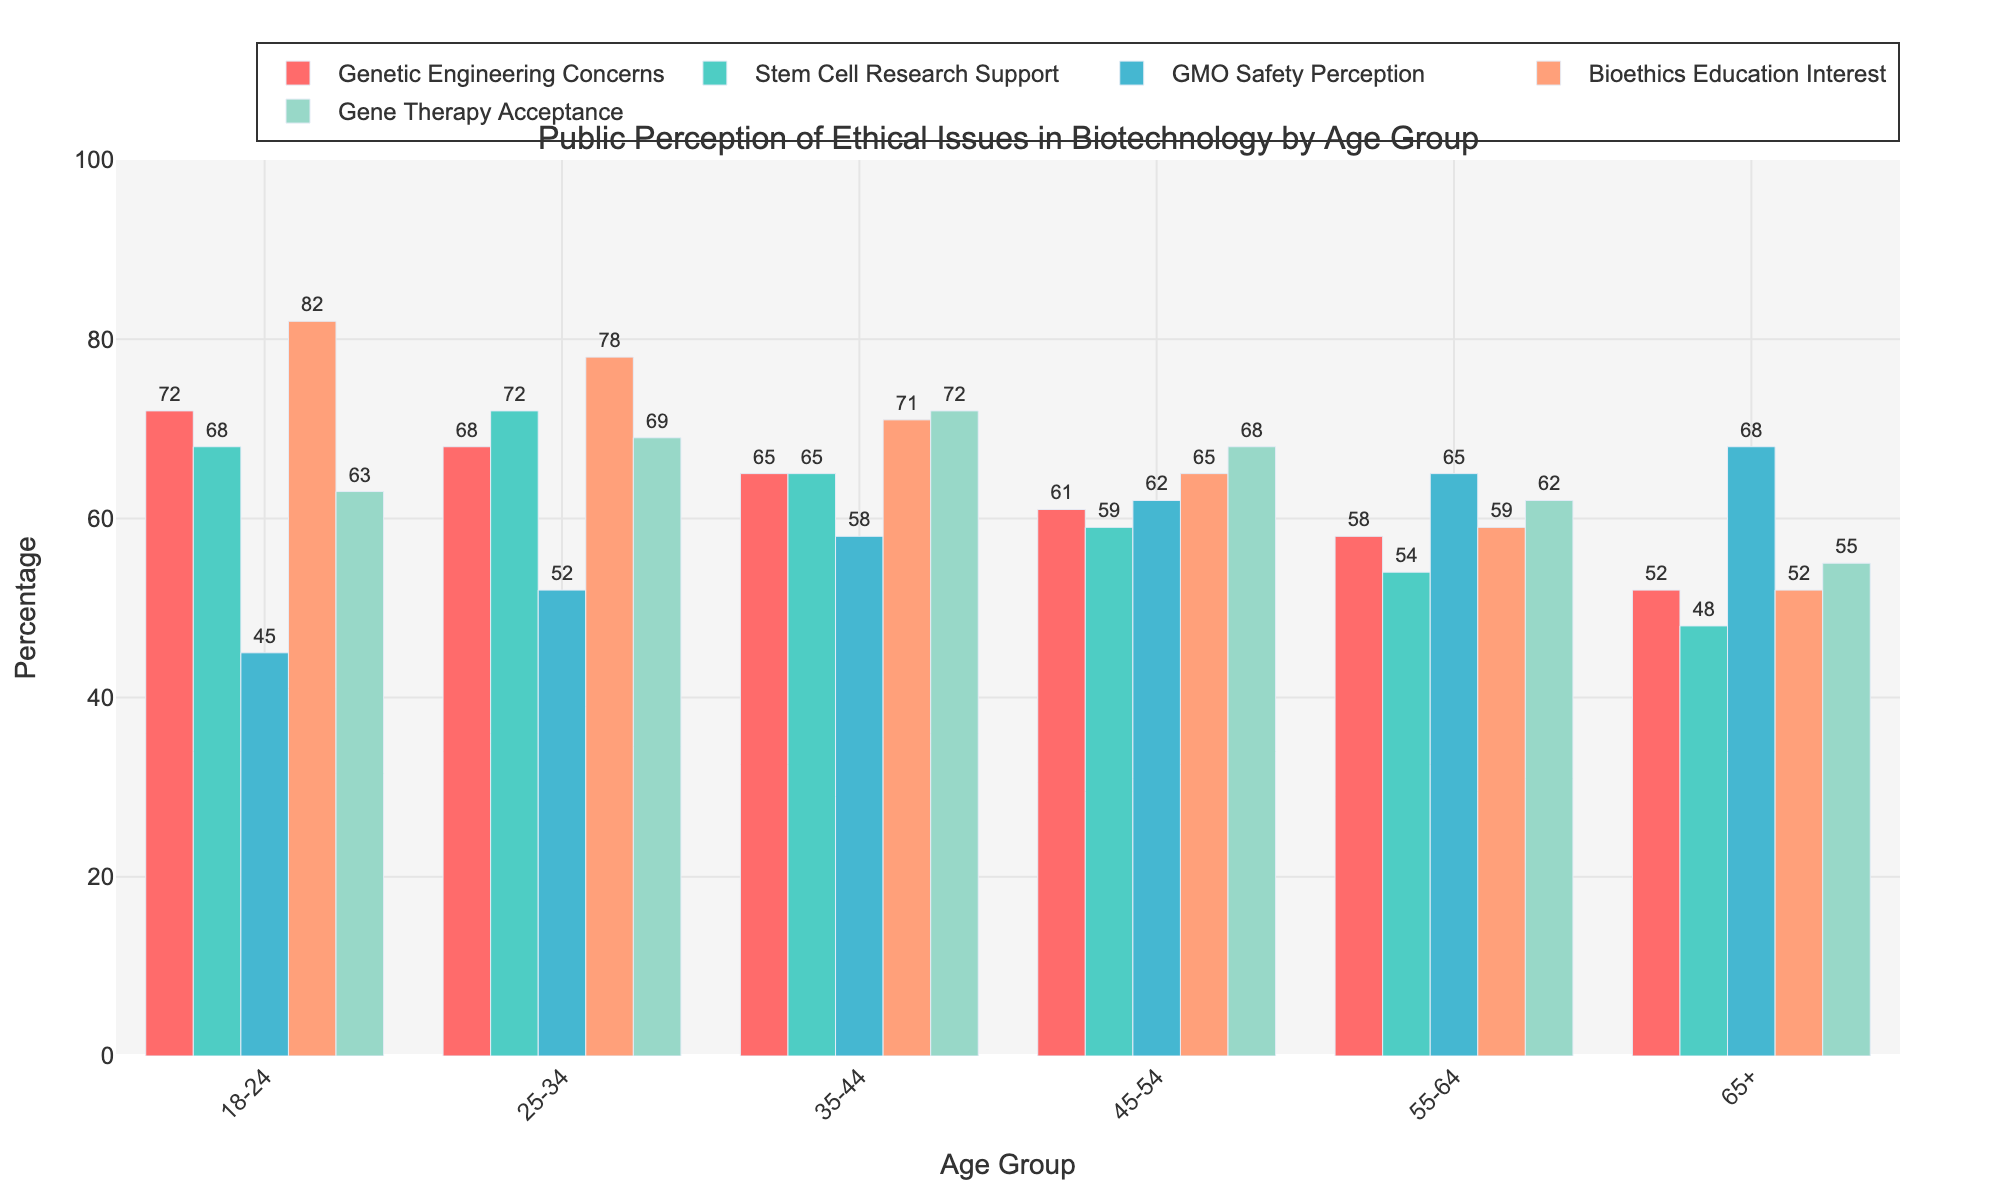What's the level of Genetic Engineering Concerns among the 18-24 age group? Look for the bar that represents the "Genetic Engineering Concerns" category for the 18-24 age group and read off the percentage value.
Answer: 72% Which age group shows the highest support for Stem Cell Research? Identify the tallest bar in the "Stem Cell Research Support" category across all age groups, then read off the corresponding age group.
Answer: 25-34 Compare the interest in Bioethics Education between the 18-24 and 65+ age groups. Find the bar heights for the "Bioethics Education Interest" category for both the 18-24 and 65+ age groups and compare them. The bar for the 18-24 age group is taller than the bar for the 65+ age group.
Answer: Higher in 18-24 What is the difference in GMO Safety Perception between the 25-34 and 55-64 age groups? Look at the percentage values for the "GMO Safety Perception" bars for both the 25-34 and 55-64 age groups, then subtract the latter from the former: 52 - 65.
Answer: -13 Which category has the least variation across age groups? Examine the range (difference between the highest and lowest values) of the bars within each category. "Gene Therapy Acceptance" ranges from 55 (65+) to 72 (35-44), amounting to the smallest difference of 17.
Answer: Gene Therapy Acceptance Is the support for Stem Cell Research increasing or decreasing with age? Observe the trend of the bar heights for the "Stem Cell Research Support" category as the age groups progress from 18-24 to 65+. The heights decrease as the age increases.
Answer: Decreasing Calculate the average acceptance of Gene Therapy across all age groups. Add the values for "Gene Therapy Acceptance" across all age groups and divide by the number of age groups: (63 + 69 + 72 + 68 + 62 + 55) / 6 = 64.83.
Answer: 64.83 Which age group has the highest concerns about Genetic Engineering? Identify the tallest bar in the "Genetic Engineering Concerns" category across all age groups and read off the corresponding age group.
Answer: 18-24 How does the interest in Bioethics Education among the 45-54 age group compare with other groups? Look at the bar height for the "Bioethics Education Interest" category for the 45-54 age group and compare with other groups. It is lower than the 18-24 and 25-34 groups but higher than the older age groups.
Answer: High compared to older groups, low compared to younger groups What is the average support for Stem Cell Research among people under 35? Add the values for "Stem Cell Research Support" for age groups 18-24 and 25-34, then divide by 2: (68 + 72) / 2 = 70.
Answer: 70 